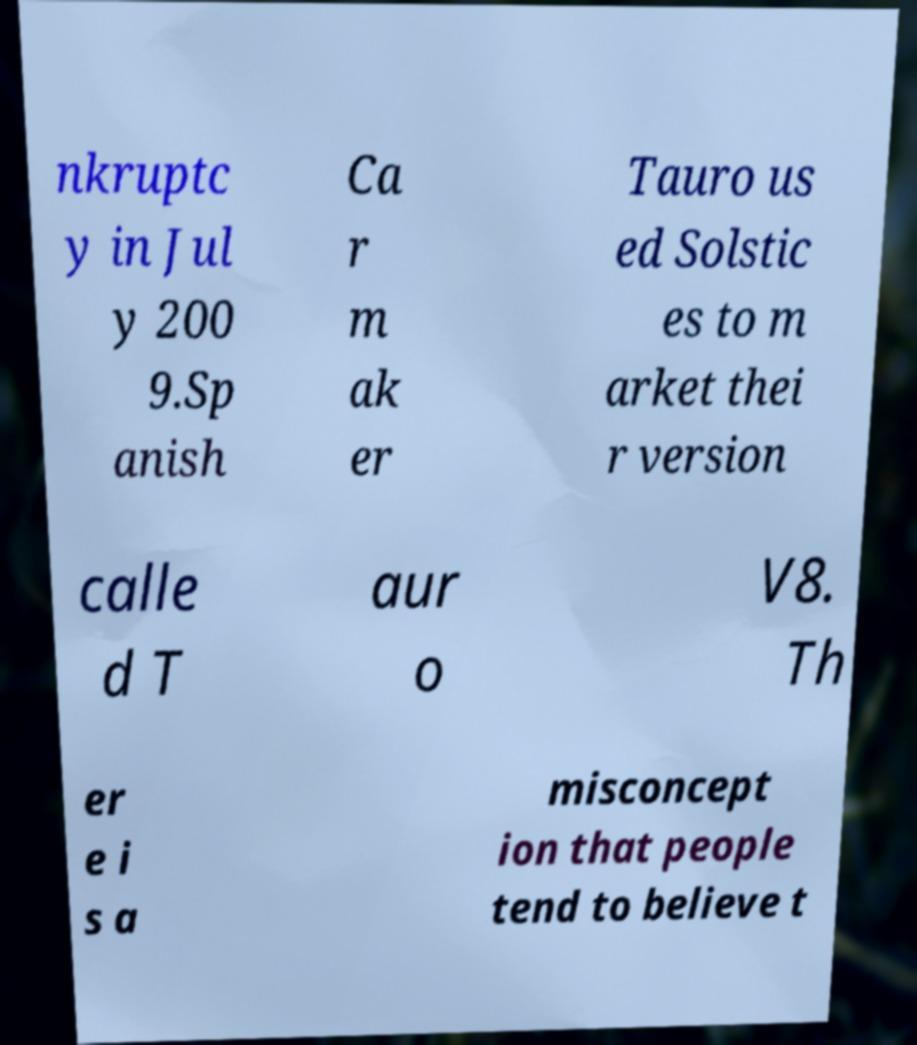Could you extract and type out the text from this image? nkruptc y in Jul y 200 9.Sp anish Ca r m ak er Tauro us ed Solstic es to m arket thei r version calle d T aur o V8. Th er e i s a misconcept ion that people tend to believe t 